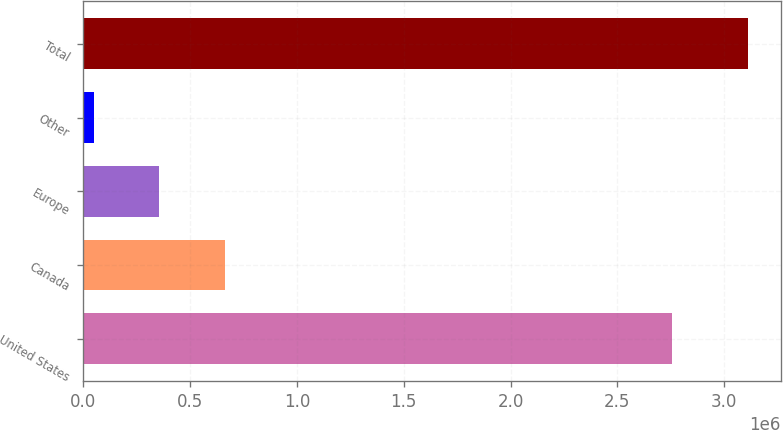<chart> <loc_0><loc_0><loc_500><loc_500><bar_chart><fcel>United States<fcel>Canada<fcel>Europe<fcel>Other<fcel>Total<nl><fcel>2.75731e+06<fcel>662505<fcel>356621<fcel>50737<fcel>3.10958e+06<nl></chart> 